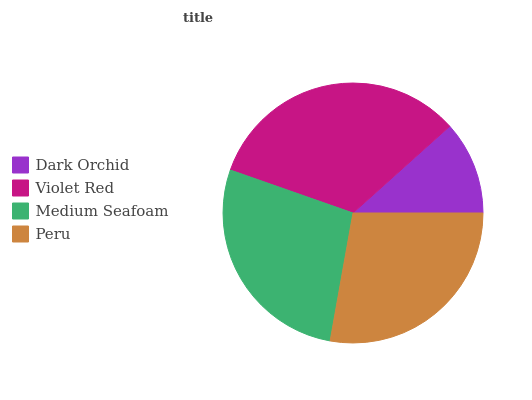Is Dark Orchid the minimum?
Answer yes or no. Yes. Is Violet Red the maximum?
Answer yes or no. Yes. Is Medium Seafoam the minimum?
Answer yes or no. No. Is Medium Seafoam the maximum?
Answer yes or no. No. Is Violet Red greater than Medium Seafoam?
Answer yes or no. Yes. Is Medium Seafoam less than Violet Red?
Answer yes or no. Yes. Is Medium Seafoam greater than Violet Red?
Answer yes or no. No. Is Violet Red less than Medium Seafoam?
Answer yes or no. No. Is Peru the high median?
Answer yes or no. Yes. Is Medium Seafoam the low median?
Answer yes or no. Yes. Is Violet Red the high median?
Answer yes or no. No. Is Violet Red the low median?
Answer yes or no. No. 